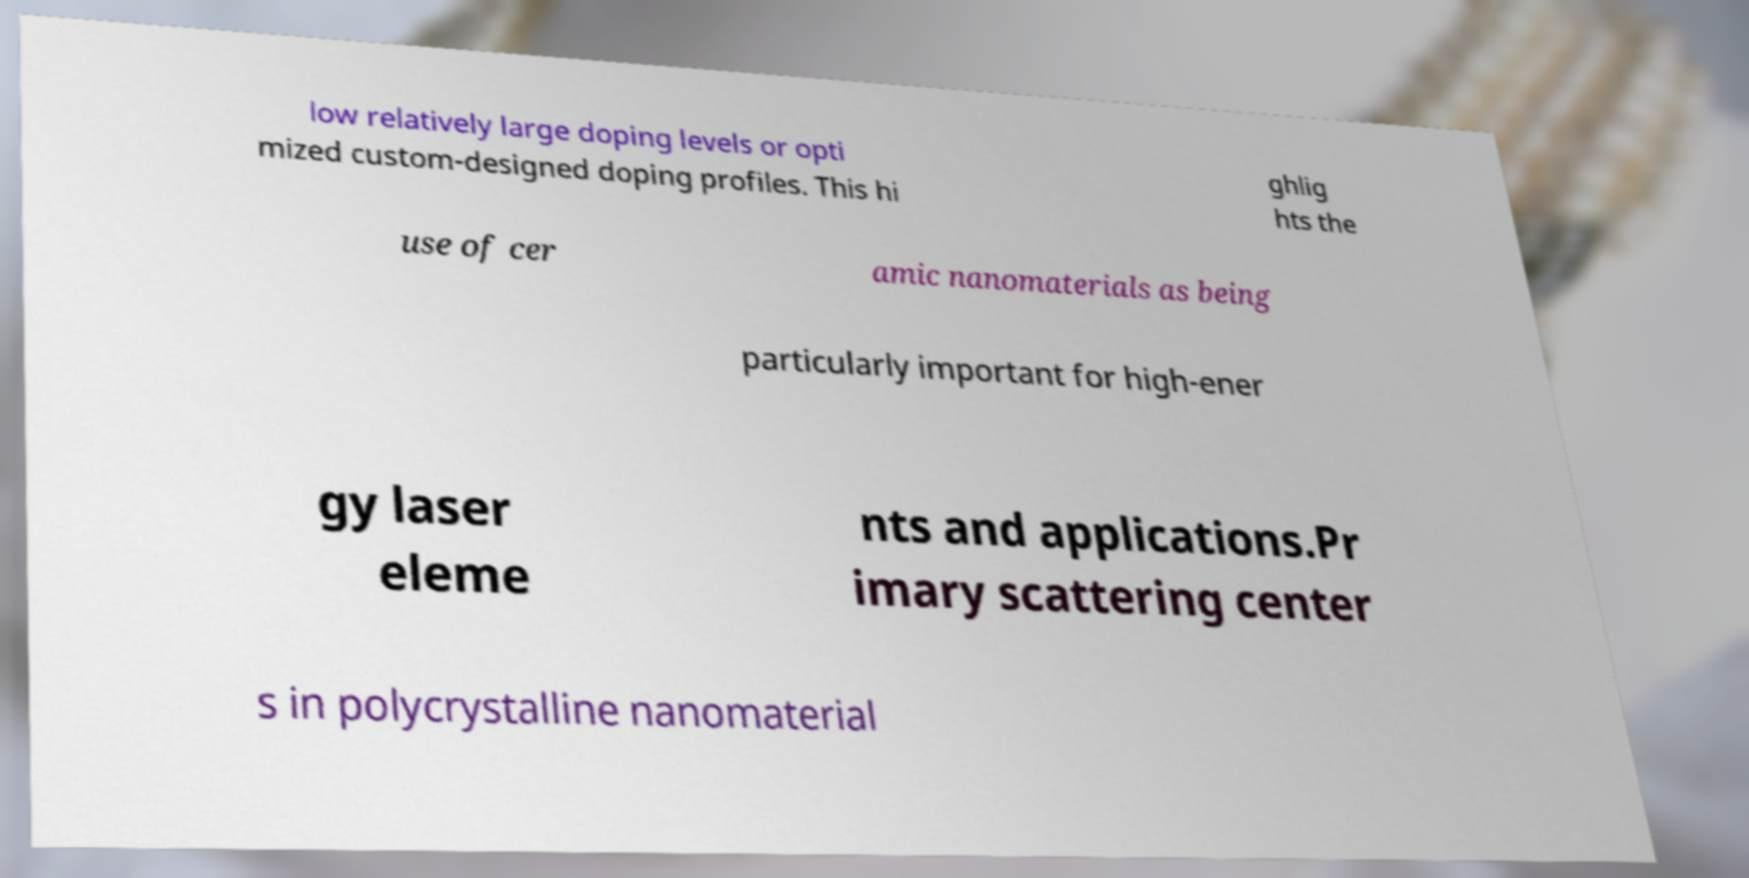For documentation purposes, I need the text within this image transcribed. Could you provide that? low relatively large doping levels or opti mized custom-designed doping profiles. This hi ghlig hts the use of cer amic nanomaterials as being particularly important for high-ener gy laser eleme nts and applications.Pr imary scattering center s in polycrystalline nanomaterial 